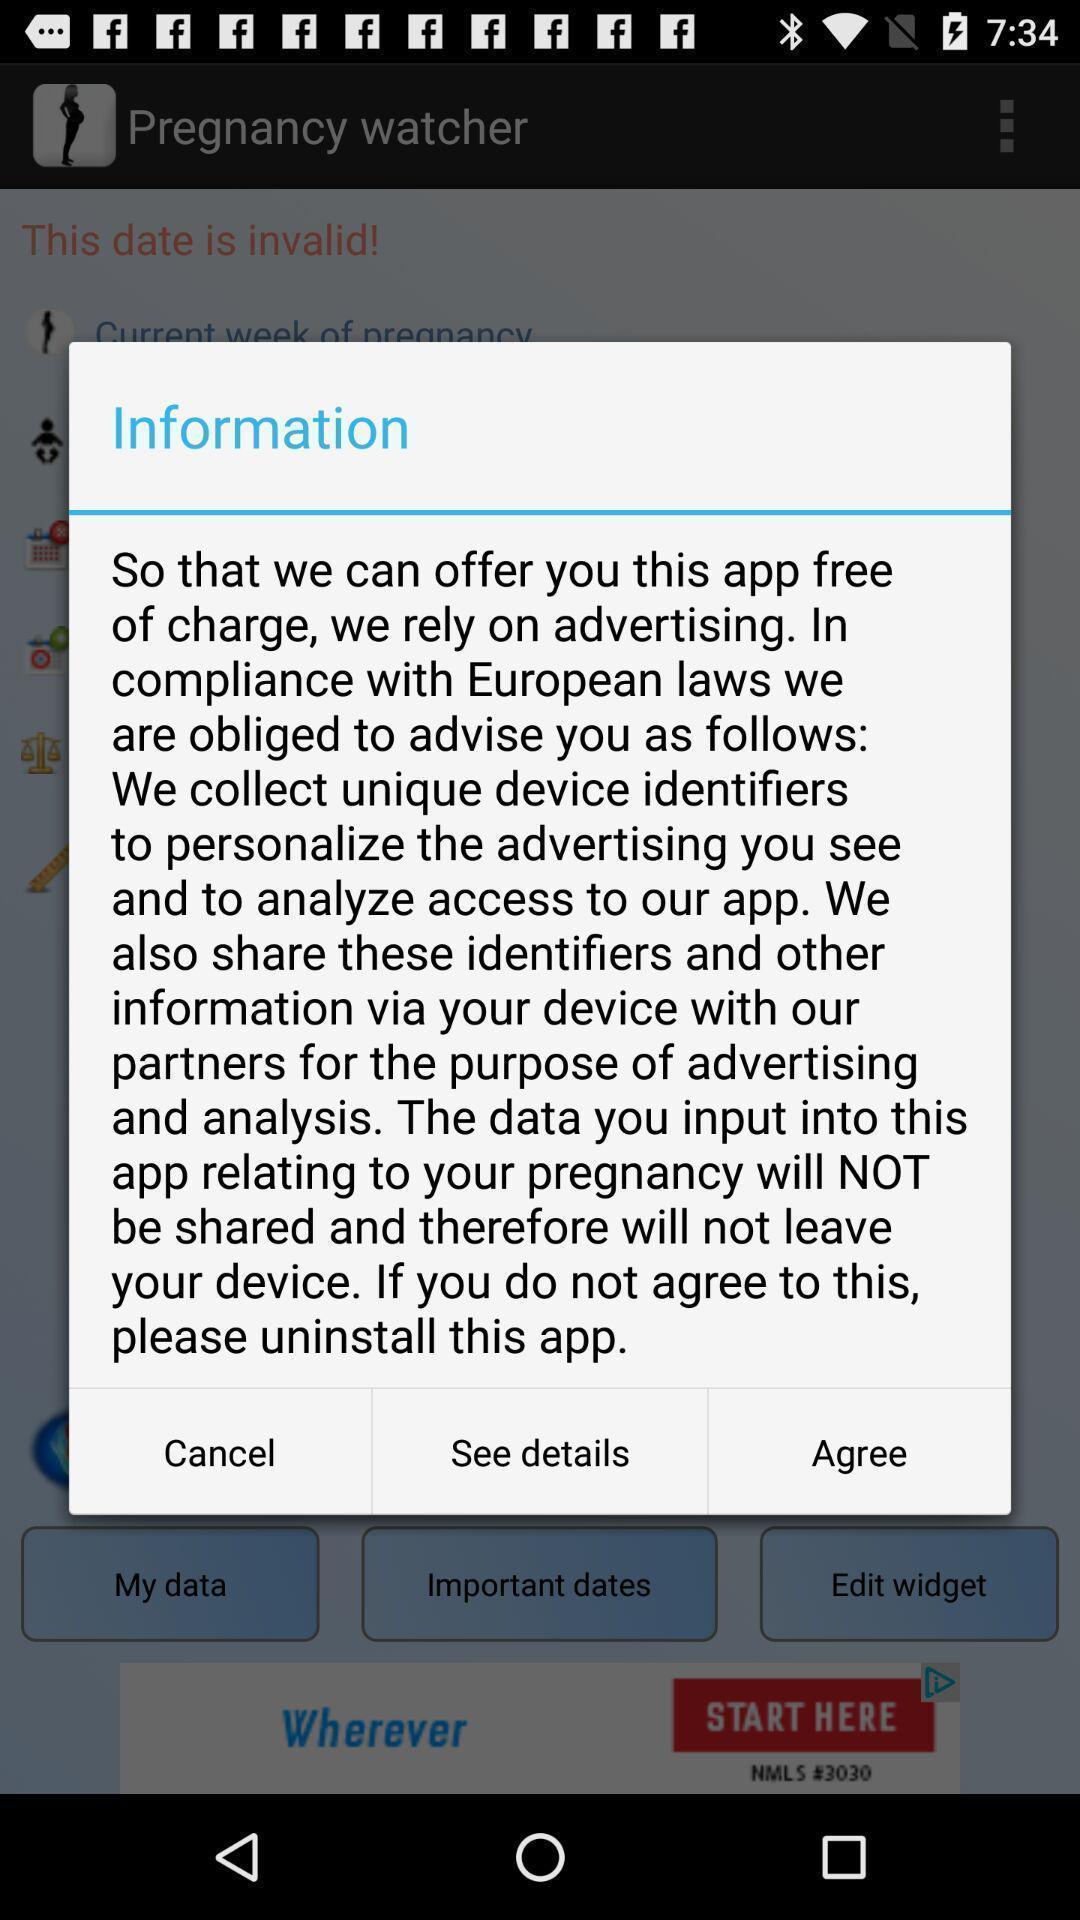Describe the content in this image. Popup showing information and agree option. 